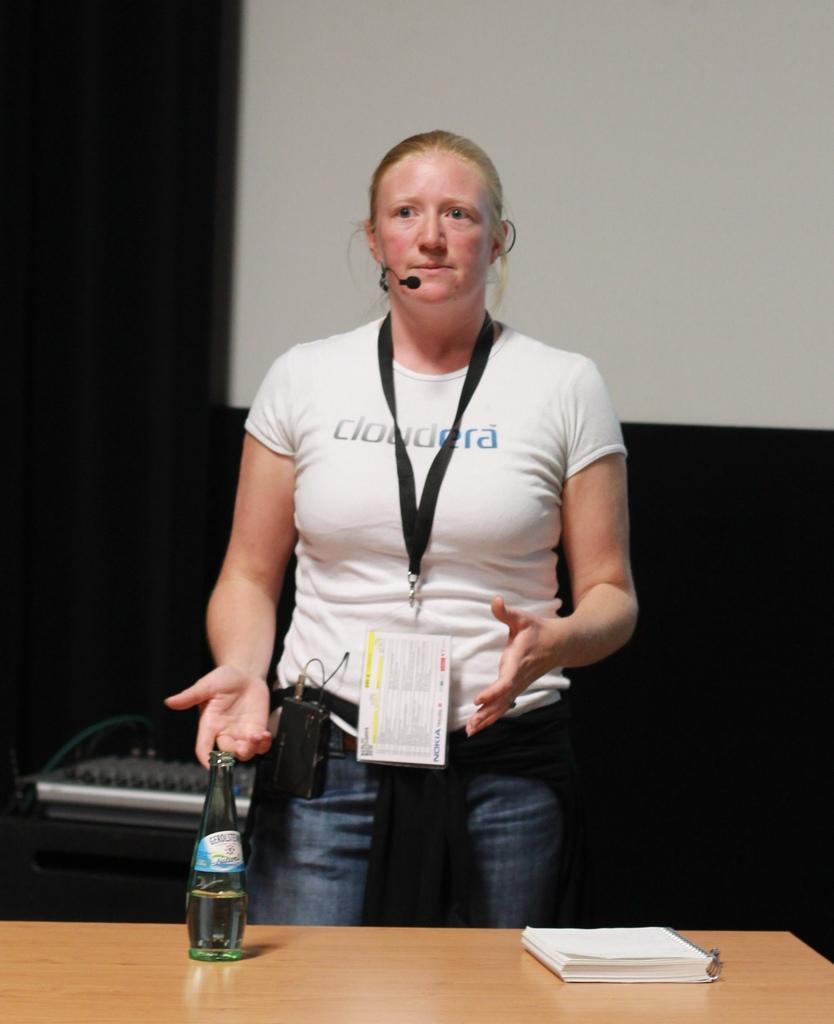How would you summarize this image in a sentence or two? Here we can see a woman standing in front of a table with book and bottle on it she is having a microphone and speaking something in it 